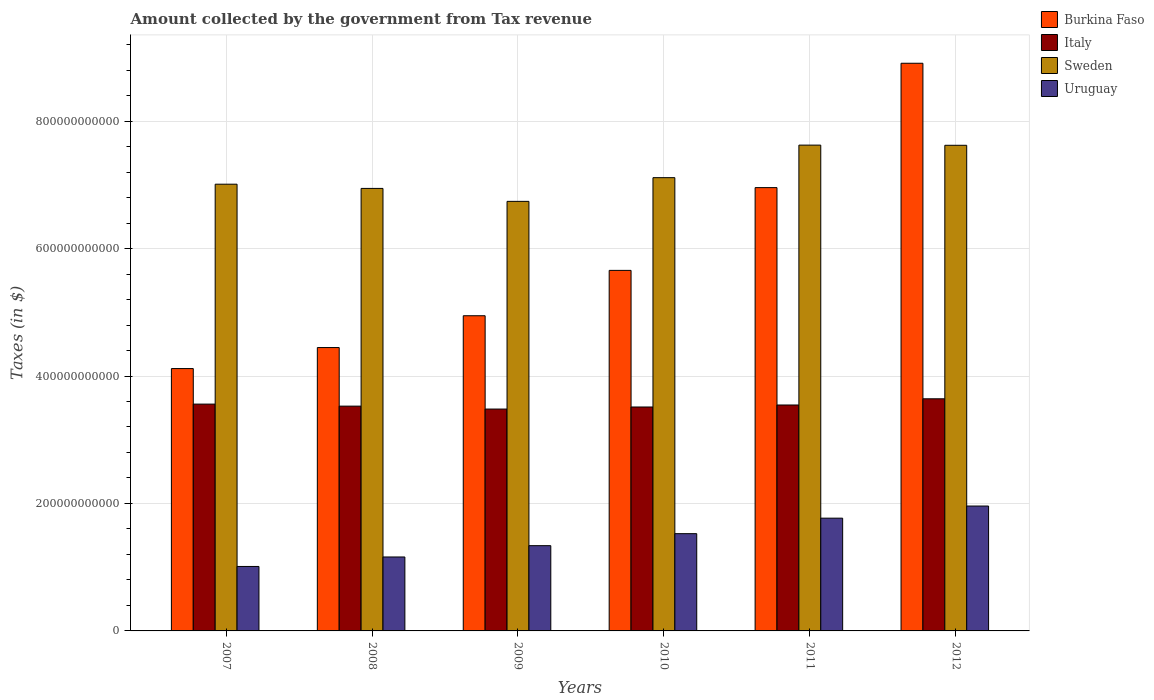How many groups of bars are there?
Provide a succinct answer. 6. How many bars are there on the 6th tick from the right?
Keep it short and to the point. 4. What is the amount collected by the government from tax revenue in Sweden in 2009?
Keep it short and to the point. 6.74e+11. Across all years, what is the maximum amount collected by the government from tax revenue in Burkina Faso?
Your response must be concise. 8.91e+11. Across all years, what is the minimum amount collected by the government from tax revenue in Uruguay?
Provide a short and direct response. 1.01e+11. In which year was the amount collected by the government from tax revenue in Italy maximum?
Keep it short and to the point. 2012. What is the total amount collected by the government from tax revenue in Burkina Faso in the graph?
Provide a succinct answer. 3.50e+12. What is the difference between the amount collected by the government from tax revenue in Italy in 2007 and that in 2009?
Your response must be concise. 7.78e+09. What is the difference between the amount collected by the government from tax revenue in Sweden in 2007 and the amount collected by the government from tax revenue in Uruguay in 2011?
Your answer should be very brief. 5.24e+11. What is the average amount collected by the government from tax revenue in Burkina Faso per year?
Make the answer very short. 5.84e+11. In the year 2010, what is the difference between the amount collected by the government from tax revenue in Burkina Faso and amount collected by the government from tax revenue in Uruguay?
Your response must be concise. 4.13e+11. In how many years, is the amount collected by the government from tax revenue in Uruguay greater than 240000000000 $?
Your answer should be compact. 0. What is the ratio of the amount collected by the government from tax revenue in Burkina Faso in 2007 to that in 2008?
Give a very brief answer. 0.93. Is the amount collected by the government from tax revenue in Italy in 2008 less than that in 2009?
Offer a very short reply. No. Is the difference between the amount collected by the government from tax revenue in Burkina Faso in 2008 and 2012 greater than the difference between the amount collected by the government from tax revenue in Uruguay in 2008 and 2012?
Give a very brief answer. No. What is the difference between the highest and the second highest amount collected by the government from tax revenue in Uruguay?
Your answer should be very brief. 1.90e+1. What is the difference between the highest and the lowest amount collected by the government from tax revenue in Burkina Faso?
Your answer should be compact. 4.79e+11. In how many years, is the amount collected by the government from tax revenue in Italy greater than the average amount collected by the government from tax revenue in Italy taken over all years?
Your response must be concise. 3. Is it the case that in every year, the sum of the amount collected by the government from tax revenue in Italy and amount collected by the government from tax revenue in Sweden is greater than the sum of amount collected by the government from tax revenue in Uruguay and amount collected by the government from tax revenue in Burkina Faso?
Give a very brief answer. Yes. What does the 4th bar from the left in 2007 represents?
Your answer should be compact. Uruguay. What does the 3rd bar from the right in 2011 represents?
Keep it short and to the point. Italy. Is it the case that in every year, the sum of the amount collected by the government from tax revenue in Uruguay and amount collected by the government from tax revenue in Sweden is greater than the amount collected by the government from tax revenue in Burkina Faso?
Make the answer very short. Yes. How many bars are there?
Give a very brief answer. 24. What is the difference between two consecutive major ticks on the Y-axis?
Your answer should be compact. 2.00e+11. Does the graph contain any zero values?
Offer a terse response. No. Where does the legend appear in the graph?
Offer a terse response. Top right. How many legend labels are there?
Your response must be concise. 4. What is the title of the graph?
Your answer should be very brief. Amount collected by the government from Tax revenue. What is the label or title of the X-axis?
Provide a succinct answer. Years. What is the label or title of the Y-axis?
Your answer should be compact. Taxes (in $). What is the Taxes (in $) in Burkina Faso in 2007?
Your response must be concise. 4.12e+11. What is the Taxes (in $) of Italy in 2007?
Make the answer very short. 3.56e+11. What is the Taxes (in $) in Sweden in 2007?
Ensure brevity in your answer.  7.01e+11. What is the Taxes (in $) in Uruguay in 2007?
Your answer should be compact. 1.01e+11. What is the Taxes (in $) of Burkina Faso in 2008?
Offer a terse response. 4.45e+11. What is the Taxes (in $) of Italy in 2008?
Make the answer very short. 3.53e+11. What is the Taxes (in $) of Sweden in 2008?
Make the answer very short. 6.94e+11. What is the Taxes (in $) in Uruguay in 2008?
Provide a succinct answer. 1.16e+11. What is the Taxes (in $) of Burkina Faso in 2009?
Your response must be concise. 4.95e+11. What is the Taxes (in $) in Italy in 2009?
Your answer should be very brief. 3.48e+11. What is the Taxes (in $) in Sweden in 2009?
Make the answer very short. 6.74e+11. What is the Taxes (in $) in Uruguay in 2009?
Provide a succinct answer. 1.34e+11. What is the Taxes (in $) of Burkina Faso in 2010?
Your response must be concise. 5.66e+11. What is the Taxes (in $) in Italy in 2010?
Offer a terse response. 3.51e+11. What is the Taxes (in $) in Sweden in 2010?
Give a very brief answer. 7.11e+11. What is the Taxes (in $) of Uruguay in 2010?
Offer a very short reply. 1.53e+11. What is the Taxes (in $) in Burkina Faso in 2011?
Provide a short and direct response. 6.96e+11. What is the Taxes (in $) in Italy in 2011?
Your answer should be very brief. 3.55e+11. What is the Taxes (in $) in Sweden in 2011?
Make the answer very short. 7.62e+11. What is the Taxes (in $) in Uruguay in 2011?
Provide a succinct answer. 1.77e+11. What is the Taxes (in $) in Burkina Faso in 2012?
Offer a very short reply. 8.91e+11. What is the Taxes (in $) of Italy in 2012?
Your answer should be very brief. 3.64e+11. What is the Taxes (in $) in Sweden in 2012?
Offer a terse response. 7.62e+11. What is the Taxes (in $) of Uruguay in 2012?
Offer a very short reply. 1.96e+11. Across all years, what is the maximum Taxes (in $) of Burkina Faso?
Your answer should be very brief. 8.91e+11. Across all years, what is the maximum Taxes (in $) of Italy?
Give a very brief answer. 3.64e+11. Across all years, what is the maximum Taxes (in $) of Sweden?
Your answer should be compact. 7.62e+11. Across all years, what is the maximum Taxes (in $) in Uruguay?
Give a very brief answer. 1.96e+11. Across all years, what is the minimum Taxes (in $) of Burkina Faso?
Give a very brief answer. 4.12e+11. Across all years, what is the minimum Taxes (in $) of Italy?
Your answer should be compact. 3.48e+11. Across all years, what is the minimum Taxes (in $) of Sweden?
Give a very brief answer. 6.74e+11. Across all years, what is the minimum Taxes (in $) of Uruguay?
Give a very brief answer. 1.01e+11. What is the total Taxes (in $) of Burkina Faso in the graph?
Your answer should be compact. 3.50e+12. What is the total Taxes (in $) in Italy in the graph?
Offer a terse response. 2.13e+12. What is the total Taxes (in $) in Sweden in the graph?
Offer a terse response. 4.31e+12. What is the total Taxes (in $) in Uruguay in the graph?
Make the answer very short. 8.77e+11. What is the difference between the Taxes (in $) in Burkina Faso in 2007 and that in 2008?
Your answer should be very brief. -3.30e+1. What is the difference between the Taxes (in $) in Italy in 2007 and that in 2008?
Keep it short and to the point. 3.18e+09. What is the difference between the Taxes (in $) of Sweden in 2007 and that in 2008?
Give a very brief answer. 6.62e+09. What is the difference between the Taxes (in $) in Uruguay in 2007 and that in 2008?
Offer a very short reply. -1.49e+1. What is the difference between the Taxes (in $) in Burkina Faso in 2007 and that in 2009?
Your response must be concise. -8.29e+1. What is the difference between the Taxes (in $) of Italy in 2007 and that in 2009?
Give a very brief answer. 7.78e+09. What is the difference between the Taxes (in $) in Sweden in 2007 and that in 2009?
Ensure brevity in your answer.  2.69e+1. What is the difference between the Taxes (in $) of Uruguay in 2007 and that in 2009?
Provide a succinct answer. -3.26e+1. What is the difference between the Taxes (in $) in Burkina Faso in 2007 and that in 2010?
Your answer should be compact. -1.54e+11. What is the difference between the Taxes (in $) of Italy in 2007 and that in 2010?
Your answer should be compact. 4.54e+09. What is the difference between the Taxes (in $) in Sweden in 2007 and that in 2010?
Keep it short and to the point. -1.03e+1. What is the difference between the Taxes (in $) in Uruguay in 2007 and that in 2010?
Provide a succinct answer. -5.15e+1. What is the difference between the Taxes (in $) in Burkina Faso in 2007 and that in 2011?
Keep it short and to the point. -2.84e+11. What is the difference between the Taxes (in $) in Italy in 2007 and that in 2011?
Offer a very short reply. 1.41e+09. What is the difference between the Taxes (in $) in Sweden in 2007 and that in 2011?
Your response must be concise. -6.13e+1. What is the difference between the Taxes (in $) in Uruguay in 2007 and that in 2011?
Offer a terse response. -7.58e+1. What is the difference between the Taxes (in $) of Burkina Faso in 2007 and that in 2012?
Provide a short and direct response. -4.79e+11. What is the difference between the Taxes (in $) of Italy in 2007 and that in 2012?
Your answer should be compact. -8.33e+09. What is the difference between the Taxes (in $) of Sweden in 2007 and that in 2012?
Your answer should be very brief. -6.11e+1. What is the difference between the Taxes (in $) in Uruguay in 2007 and that in 2012?
Your response must be concise. -9.48e+1. What is the difference between the Taxes (in $) of Burkina Faso in 2008 and that in 2009?
Provide a succinct answer. -4.99e+1. What is the difference between the Taxes (in $) of Italy in 2008 and that in 2009?
Your answer should be compact. 4.60e+09. What is the difference between the Taxes (in $) in Sweden in 2008 and that in 2009?
Ensure brevity in your answer.  2.03e+1. What is the difference between the Taxes (in $) in Uruguay in 2008 and that in 2009?
Your answer should be very brief. -1.77e+1. What is the difference between the Taxes (in $) of Burkina Faso in 2008 and that in 2010?
Give a very brief answer. -1.21e+11. What is the difference between the Taxes (in $) in Italy in 2008 and that in 2010?
Give a very brief answer. 1.37e+09. What is the difference between the Taxes (in $) of Sweden in 2008 and that in 2010?
Provide a succinct answer. -1.69e+1. What is the difference between the Taxes (in $) of Uruguay in 2008 and that in 2010?
Keep it short and to the point. -3.66e+1. What is the difference between the Taxes (in $) of Burkina Faso in 2008 and that in 2011?
Make the answer very short. -2.51e+11. What is the difference between the Taxes (in $) of Italy in 2008 and that in 2011?
Ensure brevity in your answer.  -1.77e+09. What is the difference between the Taxes (in $) in Sweden in 2008 and that in 2011?
Offer a very short reply. -6.79e+1. What is the difference between the Taxes (in $) of Uruguay in 2008 and that in 2011?
Give a very brief answer. -6.09e+1. What is the difference between the Taxes (in $) of Burkina Faso in 2008 and that in 2012?
Your answer should be very brief. -4.46e+11. What is the difference between the Taxes (in $) in Italy in 2008 and that in 2012?
Your answer should be compact. -1.15e+1. What is the difference between the Taxes (in $) of Sweden in 2008 and that in 2012?
Make the answer very short. -6.77e+1. What is the difference between the Taxes (in $) in Uruguay in 2008 and that in 2012?
Keep it short and to the point. -7.99e+1. What is the difference between the Taxes (in $) in Burkina Faso in 2009 and that in 2010?
Offer a terse response. -7.12e+1. What is the difference between the Taxes (in $) of Italy in 2009 and that in 2010?
Offer a terse response. -3.24e+09. What is the difference between the Taxes (in $) of Sweden in 2009 and that in 2010?
Offer a very short reply. -3.72e+1. What is the difference between the Taxes (in $) of Uruguay in 2009 and that in 2010?
Offer a very short reply. -1.88e+1. What is the difference between the Taxes (in $) in Burkina Faso in 2009 and that in 2011?
Ensure brevity in your answer.  -2.01e+11. What is the difference between the Taxes (in $) of Italy in 2009 and that in 2011?
Your answer should be very brief. -6.37e+09. What is the difference between the Taxes (in $) of Sweden in 2009 and that in 2011?
Give a very brief answer. -8.83e+1. What is the difference between the Taxes (in $) of Uruguay in 2009 and that in 2011?
Offer a very short reply. -4.32e+1. What is the difference between the Taxes (in $) of Burkina Faso in 2009 and that in 2012?
Offer a terse response. -3.96e+11. What is the difference between the Taxes (in $) of Italy in 2009 and that in 2012?
Keep it short and to the point. -1.61e+1. What is the difference between the Taxes (in $) of Sweden in 2009 and that in 2012?
Provide a short and direct response. -8.80e+1. What is the difference between the Taxes (in $) of Uruguay in 2009 and that in 2012?
Ensure brevity in your answer.  -6.22e+1. What is the difference between the Taxes (in $) of Burkina Faso in 2010 and that in 2011?
Your answer should be very brief. -1.30e+11. What is the difference between the Taxes (in $) of Italy in 2010 and that in 2011?
Offer a very short reply. -3.14e+09. What is the difference between the Taxes (in $) of Sweden in 2010 and that in 2011?
Give a very brief answer. -5.11e+1. What is the difference between the Taxes (in $) of Uruguay in 2010 and that in 2011?
Provide a succinct answer. -2.43e+1. What is the difference between the Taxes (in $) of Burkina Faso in 2010 and that in 2012?
Ensure brevity in your answer.  -3.25e+11. What is the difference between the Taxes (in $) of Italy in 2010 and that in 2012?
Provide a short and direct response. -1.29e+1. What is the difference between the Taxes (in $) of Sweden in 2010 and that in 2012?
Your answer should be compact. -5.08e+1. What is the difference between the Taxes (in $) of Uruguay in 2010 and that in 2012?
Your answer should be compact. -4.34e+1. What is the difference between the Taxes (in $) of Burkina Faso in 2011 and that in 2012?
Ensure brevity in your answer.  -1.95e+11. What is the difference between the Taxes (in $) in Italy in 2011 and that in 2012?
Ensure brevity in your answer.  -9.73e+09. What is the difference between the Taxes (in $) of Sweden in 2011 and that in 2012?
Provide a short and direct response. 2.64e+08. What is the difference between the Taxes (in $) in Uruguay in 2011 and that in 2012?
Provide a short and direct response. -1.90e+1. What is the difference between the Taxes (in $) in Burkina Faso in 2007 and the Taxes (in $) in Italy in 2008?
Your answer should be very brief. 5.89e+1. What is the difference between the Taxes (in $) of Burkina Faso in 2007 and the Taxes (in $) of Sweden in 2008?
Your response must be concise. -2.83e+11. What is the difference between the Taxes (in $) of Burkina Faso in 2007 and the Taxes (in $) of Uruguay in 2008?
Keep it short and to the point. 2.96e+11. What is the difference between the Taxes (in $) of Italy in 2007 and the Taxes (in $) of Sweden in 2008?
Your answer should be very brief. -3.38e+11. What is the difference between the Taxes (in $) in Italy in 2007 and the Taxes (in $) in Uruguay in 2008?
Make the answer very short. 2.40e+11. What is the difference between the Taxes (in $) of Sweden in 2007 and the Taxes (in $) of Uruguay in 2008?
Keep it short and to the point. 5.85e+11. What is the difference between the Taxes (in $) of Burkina Faso in 2007 and the Taxes (in $) of Italy in 2009?
Offer a terse response. 6.35e+1. What is the difference between the Taxes (in $) of Burkina Faso in 2007 and the Taxes (in $) of Sweden in 2009?
Provide a succinct answer. -2.62e+11. What is the difference between the Taxes (in $) of Burkina Faso in 2007 and the Taxes (in $) of Uruguay in 2009?
Keep it short and to the point. 2.78e+11. What is the difference between the Taxes (in $) of Italy in 2007 and the Taxes (in $) of Sweden in 2009?
Provide a short and direct response. -3.18e+11. What is the difference between the Taxes (in $) of Italy in 2007 and the Taxes (in $) of Uruguay in 2009?
Provide a short and direct response. 2.22e+11. What is the difference between the Taxes (in $) of Sweden in 2007 and the Taxes (in $) of Uruguay in 2009?
Offer a very short reply. 5.67e+11. What is the difference between the Taxes (in $) of Burkina Faso in 2007 and the Taxes (in $) of Italy in 2010?
Provide a succinct answer. 6.03e+1. What is the difference between the Taxes (in $) of Burkina Faso in 2007 and the Taxes (in $) of Sweden in 2010?
Make the answer very short. -3.00e+11. What is the difference between the Taxes (in $) of Burkina Faso in 2007 and the Taxes (in $) of Uruguay in 2010?
Your response must be concise. 2.59e+11. What is the difference between the Taxes (in $) in Italy in 2007 and the Taxes (in $) in Sweden in 2010?
Offer a very short reply. -3.55e+11. What is the difference between the Taxes (in $) in Italy in 2007 and the Taxes (in $) in Uruguay in 2010?
Offer a terse response. 2.03e+11. What is the difference between the Taxes (in $) of Sweden in 2007 and the Taxes (in $) of Uruguay in 2010?
Keep it short and to the point. 5.48e+11. What is the difference between the Taxes (in $) in Burkina Faso in 2007 and the Taxes (in $) in Italy in 2011?
Provide a short and direct response. 5.72e+1. What is the difference between the Taxes (in $) of Burkina Faso in 2007 and the Taxes (in $) of Sweden in 2011?
Your answer should be very brief. -3.51e+11. What is the difference between the Taxes (in $) of Burkina Faso in 2007 and the Taxes (in $) of Uruguay in 2011?
Provide a succinct answer. 2.35e+11. What is the difference between the Taxes (in $) of Italy in 2007 and the Taxes (in $) of Sweden in 2011?
Provide a short and direct response. -4.06e+11. What is the difference between the Taxes (in $) of Italy in 2007 and the Taxes (in $) of Uruguay in 2011?
Offer a very short reply. 1.79e+11. What is the difference between the Taxes (in $) of Sweden in 2007 and the Taxes (in $) of Uruguay in 2011?
Provide a short and direct response. 5.24e+11. What is the difference between the Taxes (in $) in Burkina Faso in 2007 and the Taxes (in $) in Italy in 2012?
Make the answer very short. 4.74e+1. What is the difference between the Taxes (in $) of Burkina Faso in 2007 and the Taxes (in $) of Sweden in 2012?
Your response must be concise. -3.50e+11. What is the difference between the Taxes (in $) of Burkina Faso in 2007 and the Taxes (in $) of Uruguay in 2012?
Make the answer very short. 2.16e+11. What is the difference between the Taxes (in $) in Italy in 2007 and the Taxes (in $) in Sweden in 2012?
Ensure brevity in your answer.  -4.06e+11. What is the difference between the Taxes (in $) in Italy in 2007 and the Taxes (in $) in Uruguay in 2012?
Give a very brief answer. 1.60e+11. What is the difference between the Taxes (in $) of Sweden in 2007 and the Taxes (in $) of Uruguay in 2012?
Your answer should be very brief. 5.05e+11. What is the difference between the Taxes (in $) of Burkina Faso in 2008 and the Taxes (in $) of Italy in 2009?
Provide a short and direct response. 9.65e+1. What is the difference between the Taxes (in $) in Burkina Faso in 2008 and the Taxes (in $) in Sweden in 2009?
Make the answer very short. -2.29e+11. What is the difference between the Taxes (in $) of Burkina Faso in 2008 and the Taxes (in $) of Uruguay in 2009?
Offer a very short reply. 3.11e+11. What is the difference between the Taxes (in $) in Italy in 2008 and the Taxes (in $) in Sweden in 2009?
Keep it short and to the point. -3.21e+11. What is the difference between the Taxes (in $) in Italy in 2008 and the Taxes (in $) in Uruguay in 2009?
Provide a short and direct response. 2.19e+11. What is the difference between the Taxes (in $) in Sweden in 2008 and the Taxes (in $) in Uruguay in 2009?
Your response must be concise. 5.61e+11. What is the difference between the Taxes (in $) of Burkina Faso in 2008 and the Taxes (in $) of Italy in 2010?
Offer a very short reply. 9.33e+1. What is the difference between the Taxes (in $) in Burkina Faso in 2008 and the Taxes (in $) in Sweden in 2010?
Offer a very short reply. -2.67e+11. What is the difference between the Taxes (in $) in Burkina Faso in 2008 and the Taxes (in $) in Uruguay in 2010?
Give a very brief answer. 2.92e+11. What is the difference between the Taxes (in $) of Italy in 2008 and the Taxes (in $) of Sweden in 2010?
Give a very brief answer. -3.58e+11. What is the difference between the Taxes (in $) in Italy in 2008 and the Taxes (in $) in Uruguay in 2010?
Your answer should be very brief. 2.00e+11. What is the difference between the Taxes (in $) of Sweden in 2008 and the Taxes (in $) of Uruguay in 2010?
Ensure brevity in your answer.  5.42e+11. What is the difference between the Taxes (in $) in Burkina Faso in 2008 and the Taxes (in $) in Italy in 2011?
Ensure brevity in your answer.  9.02e+1. What is the difference between the Taxes (in $) of Burkina Faso in 2008 and the Taxes (in $) of Sweden in 2011?
Provide a short and direct response. -3.18e+11. What is the difference between the Taxes (in $) of Burkina Faso in 2008 and the Taxes (in $) of Uruguay in 2011?
Make the answer very short. 2.68e+11. What is the difference between the Taxes (in $) of Italy in 2008 and the Taxes (in $) of Sweden in 2011?
Offer a terse response. -4.10e+11. What is the difference between the Taxes (in $) of Italy in 2008 and the Taxes (in $) of Uruguay in 2011?
Provide a succinct answer. 1.76e+11. What is the difference between the Taxes (in $) in Sweden in 2008 and the Taxes (in $) in Uruguay in 2011?
Your answer should be compact. 5.17e+11. What is the difference between the Taxes (in $) in Burkina Faso in 2008 and the Taxes (in $) in Italy in 2012?
Offer a very short reply. 8.04e+1. What is the difference between the Taxes (in $) of Burkina Faso in 2008 and the Taxes (in $) of Sweden in 2012?
Your answer should be very brief. -3.17e+11. What is the difference between the Taxes (in $) in Burkina Faso in 2008 and the Taxes (in $) in Uruguay in 2012?
Your answer should be compact. 2.49e+11. What is the difference between the Taxes (in $) of Italy in 2008 and the Taxes (in $) of Sweden in 2012?
Keep it short and to the point. -4.09e+11. What is the difference between the Taxes (in $) of Italy in 2008 and the Taxes (in $) of Uruguay in 2012?
Make the answer very short. 1.57e+11. What is the difference between the Taxes (in $) of Sweden in 2008 and the Taxes (in $) of Uruguay in 2012?
Keep it short and to the point. 4.98e+11. What is the difference between the Taxes (in $) in Burkina Faso in 2009 and the Taxes (in $) in Italy in 2010?
Make the answer very short. 1.43e+11. What is the difference between the Taxes (in $) of Burkina Faso in 2009 and the Taxes (in $) of Sweden in 2010?
Ensure brevity in your answer.  -2.17e+11. What is the difference between the Taxes (in $) of Burkina Faso in 2009 and the Taxes (in $) of Uruguay in 2010?
Your answer should be very brief. 3.42e+11. What is the difference between the Taxes (in $) of Italy in 2009 and the Taxes (in $) of Sweden in 2010?
Keep it short and to the point. -3.63e+11. What is the difference between the Taxes (in $) of Italy in 2009 and the Taxes (in $) of Uruguay in 2010?
Provide a succinct answer. 1.96e+11. What is the difference between the Taxes (in $) in Sweden in 2009 and the Taxes (in $) in Uruguay in 2010?
Your response must be concise. 5.21e+11. What is the difference between the Taxes (in $) of Burkina Faso in 2009 and the Taxes (in $) of Italy in 2011?
Give a very brief answer. 1.40e+11. What is the difference between the Taxes (in $) of Burkina Faso in 2009 and the Taxes (in $) of Sweden in 2011?
Ensure brevity in your answer.  -2.68e+11. What is the difference between the Taxes (in $) of Burkina Faso in 2009 and the Taxes (in $) of Uruguay in 2011?
Make the answer very short. 3.18e+11. What is the difference between the Taxes (in $) of Italy in 2009 and the Taxes (in $) of Sweden in 2011?
Offer a very short reply. -4.14e+11. What is the difference between the Taxes (in $) of Italy in 2009 and the Taxes (in $) of Uruguay in 2011?
Provide a short and direct response. 1.71e+11. What is the difference between the Taxes (in $) in Sweden in 2009 and the Taxes (in $) in Uruguay in 2011?
Make the answer very short. 4.97e+11. What is the difference between the Taxes (in $) in Burkina Faso in 2009 and the Taxes (in $) in Italy in 2012?
Your answer should be compact. 1.30e+11. What is the difference between the Taxes (in $) of Burkina Faso in 2009 and the Taxes (in $) of Sweden in 2012?
Provide a succinct answer. -2.67e+11. What is the difference between the Taxes (in $) in Burkina Faso in 2009 and the Taxes (in $) in Uruguay in 2012?
Make the answer very short. 2.99e+11. What is the difference between the Taxes (in $) of Italy in 2009 and the Taxes (in $) of Sweden in 2012?
Your answer should be compact. -4.14e+11. What is the difference between the Taxes (in $) in Italy in 2009 and the Taxes (in $) in Uruguay in 2012?
Your answer should be compact. 1.52e+11. What is the difference between the Taxes (in $) in Sweden in 2009 and the Taxes (in $) in Uruguay in 2012?
Offer a very short reply. 4.78e+11. What is the difference between the Taxes (in $) of Burkina Faso in 2010 and the Taxes (in $) of Italy in 2011?
Give a very brief answer. 2.11e+11. What is the difference between the Taxes (in $) of Burkina Faso in 2010 and the Taxes (in $) of Sweden in 2011?
Offer a very short reply. -1.97e+11. What is the difference between the Taxes (in $) in Burkina Faso in 2010 and the Taxes (in $) in Uruguay in 2011?
Provide a short and direct response. 3.89e+11. What is the difference between the Taxes (in $) of Italy in 2010 and the Taxes (in $) of Sweden in 2011?
Provide a succinct answer. -4.11e+11. What is the difference between the Taxes (in $) in Italy in 2010 and the Taxes (in $) in Uruguay in 2011?
Provide a succinct answer. 1.74e+11. What is the difference between the Taxes (in $) of Sweden in 2010 and the Taxes (in $) of Uruguay in 2011?
Keep it short and to the point. 5.34e+11. What is the difference between the Taxes (in $) of Burkina Faso in 2010 and the Taxes (in $) of Italy in 2012?
Give a very brief answer. 2.01e+11. What is the difference between the Taxes (in $) in Burkina Faso in 2010 and the Taxes (in $) in Sweden in 2012?
Your answer should be very brief. -1.96e+11. What is the difference between the Taxes (in $) in Burkina Faso in 2010 and the Taxes (in $) in Uruguay in 2012?
Your answer should be very brief. 3.70e+11. What is the difference between the Taxes (in $) of Italy in 2010 and the Taxes (in $) of Sweden in 2012?
Offer a very short reply. -4.11e+11. What is the difference between the Taxes (in $) in Italy in 2010 and the Taxes (in $) in Uruguay in 2012?
Offer a terse response. 1.55e+11. What is the difference between the Taxes (in $) in Sweden in 2010 and the Taxes (in $) in Uruguay in 2012?
Provide a succinct answer. 5.15e+11. What is the difference between the Taxes (in $) of Burkina Faso in 2011 and the Taxes (in $) of Italy in 2012?
Provide a short and direct response. 3.31e+11. What is the difference between the Taxes (in $) in Burkina Faso in 2011 and the Taxes (in $) in Sweden in 2012?
Offer a terse response. -6.64e+1. What is the difference between the Taxes (in $) in Burkina Faso in 2011 and the Taxes (in $) in Uruguay in 2012?
Offer a very short reply. 5.00e+11. What is the difference between the Taxes (in $) of Italy in 2011 and the Taxes (in $) of Sweden in 2012?
Your response must be concise. -4.08e+11. What is the difference between the Taxes (in $) of Italy in 2011 and the Taxes (in $) of Uruguay in 2012?
Offer a very short reply. 1.59e+11. What is the difference between the Taxes (in $) of Sweden in 2011 and the Taxes (in $) of Uruguay in 2012?
Give a very brief answer. 5.66e+11. What is the average Taxes (in $) of Burkina Faso per year?
Offer a very short reply. 5.84e+11. What is the average Taxes (in $) in Italy per year?
Keep it short and to the point. 3.54e+11. What is the average Taxes (in $) in Sweden per year?
Offer a terse response. 7.18e+11. What is the average Taxes (in $) in Uruguay per year?
Give a very brief answer. 1.46e+11. In the year 2007, what is the difference between the Taxes (in $) in Burkina Faso and Taxes (in $) in Italy?
Your response must be concise. 5.58e+1. In the year 2007, what is the difference between the Taxes (in $) of Burkina Faso and Taxes (in $) of Sweden?
Offer a terse response. -2.89e+11. In the year 2007, what is the difference between the Taxes (in $) of Burkina Faso and Taxes (in $) of Uruguay?
Offer a very short reply. 3.11e+11. In the year 2007, what is the difference between the Taxes (in $) in Italy and Taxes (in $) in Sweden?
Offer a terse response. -3.45e+11. In the year 2007, what is the difference between the Taxes (in $) in Italy and Taxes (in $) in Uruguay?
Your answer should be compact. 2.55e+11. In the year 2007, what is the difference between the Taxes (in $) of Sweden and Taxes (in $) of Uruguay?
Ensure brevity in your answer.  6.00e+11. In the year 2008, what is the difference between the Taxes (in $) in Burkina Faso and Taxes (in $) in Italy?
Keep it short and to the point. 9.19e+1. In the year 2008, what is the difference between the Taxes (in $) of Burkina Faso and Taxes (in $) of Sweden?
Offer a terse response. -2.50e+11. In the year 2008, what is the difference between the Taxes (in $) of Burkina Faso and Taxes (in $) of Uruguay?
Provide a succinct answer. 3.29e+11. In the year 2008, what is the difference between the Taxes (in $) in Italy and Taxes (in $) in Sweden?
Ensure brevity in your answer.  -3.42e+11. In the year 2008, what is the difference between the Taxes (in $) in Italy and Taxes (in $) in Uruguay?
Keep it short and to the point. 2.37e+11. In the year 2008, what is the difference between the Taxes (in $) of Sweden and Taxes (in $) of Uruguay?
Your answer should be compact. 5.78e+11. In the year 2009, what is the difference between the Taxes (in $) in Burkina Faso and Taxes (in $) in Italy?
Offer a terse response. 1.46e+11. In the year 2009, what is the difference between the Taxes (in $) in Burkina Faso and Taxes (in $) in Sweden?
Your answer should be compact. -1.79e+11. In the year 2009, what is the difference between the Taxes (in $) in Burkina Faso and Taxes (in $) in Uruguay?
Provide a short and direct response. 3.61e+11. In the year 2009, what is the difference between the Taxes (in $) in Italy and Taxes (in $) in Sweden?
Your answer should be compact. -3.26e+11. In the year 2009, what is the difference between the Taxes (in $) in Italy and Taxes (in $) in Uruguay?
Your answer should be very brief. 2.14e+11. In the year 2009, what is the difference between the Taxes (in $) of Sweden and Taxes (in $) of Uruguay?
Your answer should be compact. 5.40e+11. In the year 2010, what is the difference between the Taxes (in $) in Burkina Faso and Taxes (in $) in Italy?
Offer a very short reply. 2.14e+11. In the year 2010, what is the difference between the Taxes (in $) in Burkina Faso and Taxes (in $) in Sweden?
Provide a succinct answer. -1.45e+11. In the year 2010, what is the difference between the Taxes (in $) in Burkina Faso and Taxes (in $) in Uruguay?
Your answer should be compact. 4.13e+11. In the year 2010, what is the difference between the Taxes (in $) in Italy and Taxes (in $) in Sweden?
Your response must be concise. -3.60e+11. In the year 2010, what is the difference between the Taxes (in $) in Italy and Taxes (in $) in Uruguay?
Give a very brief answer. 1.99e+11. In the year 2010, what is the difference between the Taxes (in $) in Sweden and Taxes (in $) in Uruguay?
Your answer should be very brief. 5.59e+11. In the year 2011, what is the difference between the Taxes (in $) in Burkina Faso and Taxes (in $) in Italy?
Provide a succinct answer. 3.41e+11. In the year 2011, what is the difference between the Taxes (in $) of Burkina Faso and Taxes (in $) of Sweden?
Provide a succinct answer. -6.67e+1. In the year 2011, what is the difference between the Taxes (in $) of Burkina Faso and Taxes (in $) of Uruguay?
Offer a terse response. 5.19e+11. In the year 2011, what is the difference between the Taxes (in $) of Italy and Taxes (in $) of Sweden?
Offer a very short reply. -4.08e+11. In the year 2011, what is the difference between the Taxes (in $) of Italy and Taxes (in $) of Uruguay?
Provide a short and direct response. 1.78e+11. In the year 2011, what is the difference between the Taxes (in $) in Sweden and Taxes (in $) in Uruguay?
Make the answer very short. 5.85e+11. In the year 2012, what is the difference between the Taxes (in $) in Burkina Faso and Taxes (in $) in Italy?
Offer a very short reply. 5.27e+11. In the year 2012, what is the difference between the Taxes (in $) of Burkina Faso and Taxes (in $) of Sweden?
Provide a succinct answer. 1.29e+11. In the year 2012, what is the difference between the Taxes (in $) in Burkina Faso and Taxes (in $) in Uruguay?
Offer a terse response. 6.95e+11. In the year 2012, what is the difference between the Taxes (in $) of Italy and Taxes (in $) of Sweden?
Provide a succinct answer. -3.98e+11. In the year 2012, what is the difference between the Taxes (in $) of Italy and Taxes (in $) of Uruguay?
Keep it short and to the point. 1.68e+11. In the year 2012, what is the difference between the Taxes (in $) of Sweden and Taxes (in $) of Uruguay?
Provide a short and direct response. 5.66e+11. What is the ratio of the Taxes (in $) of Burkina Faso in 2007 to that in 2008?
Your response must be concise. 0.93. What is the ratio of the Taxes (in $) of Sweden in 2007 to that in 2008?
Offer a very short reply. 1.01. What is the ratio of the Taxes (in $) of Uruguay in 2007 to that in 2008?
Your response must be concise. 0.87. What is the ratio of the Taxes (in $) of Burkina Faso in 2007 to that in 2009?
Your answer should be very brief. 0.83. What is the ratio of the Taxes (in $) in Italy in 2007 to that in 2009?
Your answer should be compact. 1.02. What is the ratio of the Taxes (in $) in Sweden in 2007 to that in 2009?
Give a very brief answer. 1.04. What is the ratio of the Taxes (in $) of Uruguay in 2007 to that in 2009?
Offer a terse response. 0.76. What is the ratio of the Taxes (in $) of Burkina Faso in 2007 to that in 2010?
Your answer should be very brief. 0.73. What is the ratio of the Taxes (in $) in Italy in 2007 to that in 2010?
Your answer should be compact. 1.01. What is the ratio of the Taxes (in $) in Sweden in 2007 to that in 2010?
Make the answer very short. 0.99. What is the ratio of the Taxes (in $) of Uruguay in 2007 to that in 2010?
Give a very brief answer. 0.66. What is the ratio of the Taxes (in $) in Burkina Faso in 2007 to that in 2011?
Offer a terse response. 0.59. What is the ratio of the Taxes (in $) in Sweden in 2007 to that in 2011?
Offer a terse response. 0.92. What is the ratio of the Taxes (in $) of Uruguay in 2007 to that in 2011?
Offer a very short reply. 0.57. What is the ratio of the Taxes (in $) in Burkina Faso in 2007 to that in 2012?
Make the answer very short. 0.46. What is the ratio of the Taxes (in $) in Italy in 2007 to that in 2012?
Keep it short and to the point. 0.98. What is the ratio of the Taxes (in $) in Sweden in 2007 to that in 2012?
Make the answer very short. 0.92. What is the ratio of the Taxes (in $) in Uruguay in 2007 to that in 2012?
Your answer should be very brief. 0.52. What is the ratio of the Taxes (in $) in Burkina Faso in 2008 to that in 2009?
Your answer should be very brief. 0.9. What is the ratio of the Taxes (in $) of Italy in 2008 to that in 2009?
Your answer should be very brief. 1.01. What is the ratio of the Taxes (in $) in Sweden in 2008 to that in 2009?
Offer a very short reply. 1.03. What is the ratio of the Taxes (in $) of Uruguay in 2008 to that in 2009?
Your response must be concise. 0.87. What is the ratio of the Taxes (in $) of Burkina Faso in 2008 to that in 2010?
Keep it short and to the point. 0.79. What is the ratio of the Taxes (in $) in Italy in 2008 to that in 2010?
Ensure brevity in your answer.  1. What is the ratio of the Taxes (in $) of Sweden in 2008 to that in 2010?
Your response must be concise. 0.98. What is the ratio of the Taxes (in $) in Uruguay in 2008 to that in 2010?
Ensure brevity in your answer.  0.76. What is the ratio of the Taxes (in $) of Burkina Faso in 2008 to that in 2011?
Offer a terse response. 0.64. What is the ratio of the Taxes (in $) in Italy in 2008 to that in 2011?
Ensure brevity in your answer.  0.99. What is the ratio of the Taxes (in $) in Sweden in 2008 to that in 2011?
Make the answer very short. 0.91. What is the ratio of the Taxes (in $) in Uruguay in 2008 to that in 2011?
Your answer should be compact. 0.66. What is the ratio of the Taxes (in $) in Burkina Faso in 2008 to that in 2012?
Give a very brief answer. 0.5. What is the ratio of the Taxes (in $) in Italy in 2008 to that in 2012?
Your response must be concise. 0.97. What is the ratio of the Taxes (in $) of Sweden in 2008 to that in 2012?
Give a very brief answer. 0.91. What is the ratio of the Taxes (in $) in Uruguay in 2008 to that in 2012?
Your response must be concise. 0.59. What is the ratio of the Taxes (in $) of Burkina Faso in 2009 to that in 2010?
Ensure brevity in your answer.  0.87. What is the ratio of the Taxes (in $) in Italy in 2009 to that in 2010?
Make the answer very short. 0.99. What is the ratio of the Taxes (in $) in Sweden in 2009 to that in 2010?
Offer a terse response. 0.95. What is the ratio of the Taxes (in $) in Uruguay in 2009 to that in 2010?
Offer a terse response. 0.88. What is the ratio of the Taxes (in $) of Burkina Faso in 2009 to that in 2011?
Your response must be concise. 0.71. What is the ratio of the Taxes (in $) of Sweden in 2009 to that in 2011?
Your answer should be very brief. 0.88. What is the ratio of the Taxes (in $) in Uruguay in 2009 to that in 2011?
Offer a very short reply. 0.76. What is the ratio of the Taxes (in $) in Burkina Faso in 2009 to that in 2012?
Keep it short and to the point. 0.56. What is the ratio of the Taxes (in $) in Italy in 2009 to that in 2012?
Your answer should be compact. 0.96. What is the ratio of the Taxes (in $) of Sweden in 2009 to that in 2012?
Your response must be concise. 0.88. What is the ratio of the Taxes (in $) of Uruguay in 2009 to that in 2012?
Provide a succinct answer. 0.68. What is the ratio of the Taxes (in $) in Burkina Faso in 2010 to that in 2011?
Ensure brevity in your answer.  0.81. What is the ratio of the Taxes (in $) of Italy in 2010 to that in 2011?
Give a very brief answer. 0.99. What is the ratio of the Taxes (in $) of Sweden in 2010 to that in 2011?
Provide a short and direct response. 0.93. What is the ratio of the Taxes (in $) of Uruguay in 2010 to that in 2011?
Offer a terse response. 0.86. What is the ratio of the Taxes (in $) in Burkina Faso in 2010 to that in 2012?
Your response must be concise. 0.64. What is the ratio of the Taxes (in $) in Italy in 2010 to that in 2012?
Your response must be concise. 0.96. What is the ratio of the Taxes (in $) of Sweden in 2010 to that in 2012?
Your answer should be compact. 0.93. What is the ratio of the Taxes (in $) of Uruguay in 2010 to that in 2012?
Offer a terse response. 0.78. What is the ratio of the Taxes (in $) in Burkina Faso in 2011 to that in 2012?
Your answer should be compact. 0.78. What is the ratio of the Taxes (in $) in Italy in 2011 to that in 2012?
Give a very brief answer. 0.97. What is the ratio of the Taxes (in $) in Uruguay in 2011 to that in 2012?
Give a very brief answer. 0.9. What is the difference between the highest and the second highest Taxes (in $) in Burkina Faso?
Your answer should be compact. 1.95e+11. What is the difference between the highest and the second highest Taxes (in $) of Italy?
Keep it short and to the point. 8.33e+09. What is the difference between the highest and the second highest Taxes (in $) in Sweden?
Your answer should be compact. 2.64e+08. What is the difference between the highest and the second highest Taxes (in $) in Uruguay?
Your response must be concise. 1.90e+1. What is the difference between the highest and the lowest Taxes (in $) of Burkina Faso?
Offer a very short reply. 4.79e+11. What is the difference between the highest and the lowest Taxes (in $) in Italy?
Your answer should be compact. 1.61e+1. What is the difference between the highest and the lowest Taxes (in $) of Sweden?
Offer a terse response. 8.83e+1. What is the difference between the highest and the lowest Taxes (in $) in Uruguay?
Your response must be concise. 9.48e+1. 